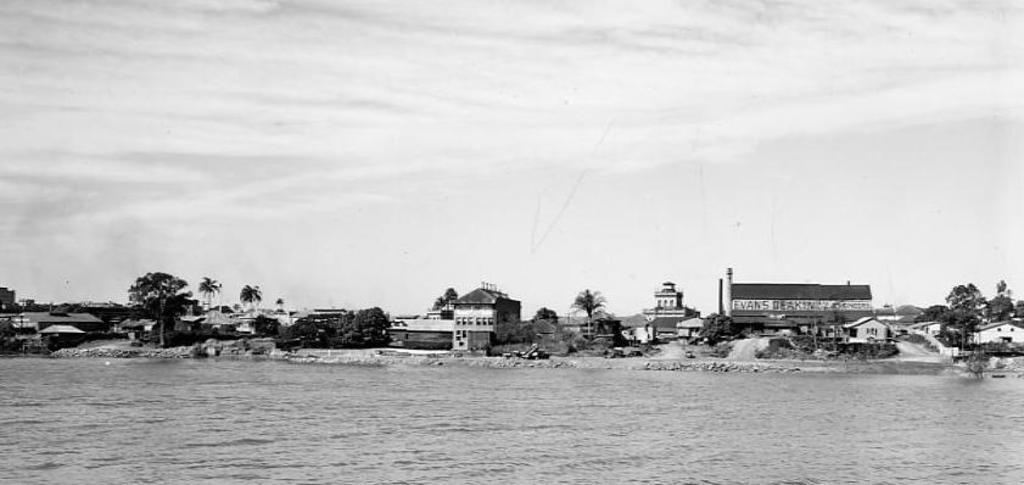Please provide a concise description of this image. In this image at the bottom there is a river, in the background there are some houses, trees and sand. On the top of the image there is sky. 